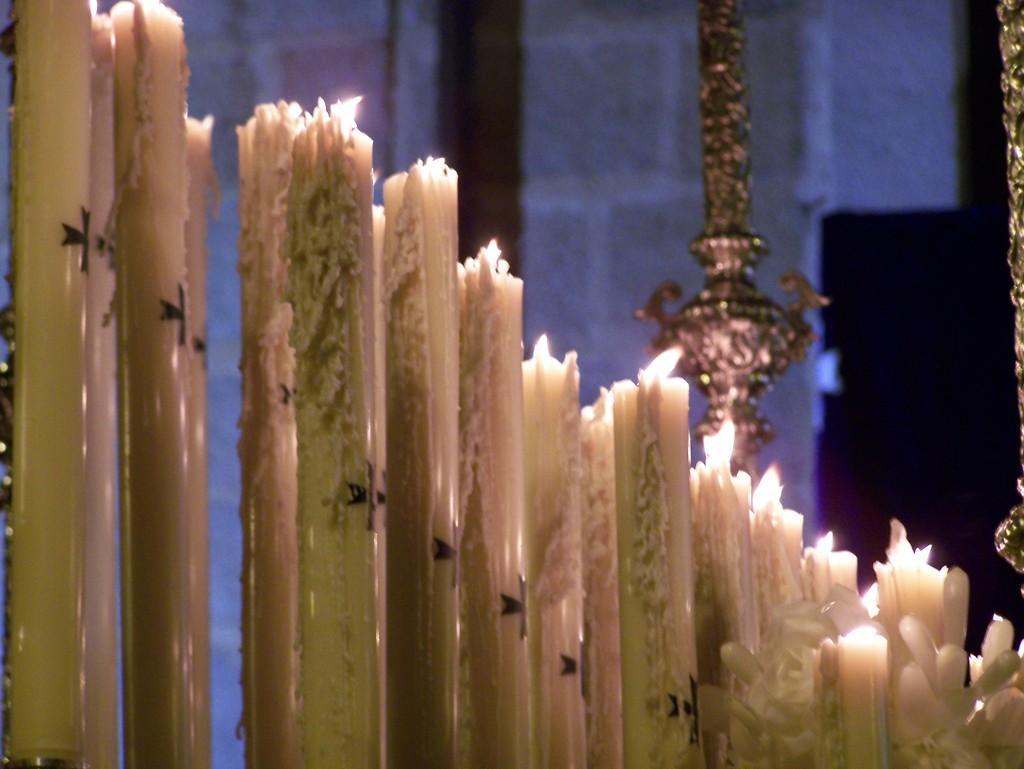Describe this image in one or two sentences. In this image we can we can see many candles with flames. In the right bottom corner there are flowers. In the back there is a metal object. In the background there is a wall. 